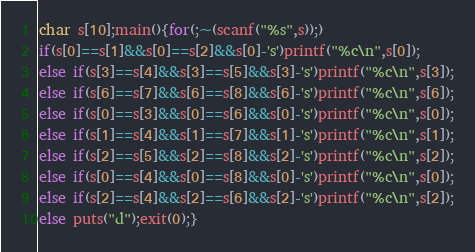Convert code to text. <code><loc_0><loc_0><loc_500><loc_500><_C_>char s[10];main(){for(;~(scanf("%s",s));)
if(s[0]==s[1]&&s[0]==s[2]&&s[0]-'s')printf("%c\n",s[0]);
else if(s[3]==s[4]&&s[3]==s[5]&&s[3]-'s')printf("%c\n",s[3]);
else if(s[6]==s[7]&&s[6]==s[8]&&s[6]-'s')printf("%c\n",s[6]);
else if(s[0]==s[3]&&s[0]==s[6]&&s[0]-'s')printf("%c\n",s[0]);
else if(s[1]==s[4]&&s[1]==s[7]&&s[1]-'s')printf("%c\n",s[1]);
else if(s[2]==s[5]&&s[2]==s[8]&&s[2]-'s')printf("%c\n",s[2]);
else if(s[0]==s[4]&&s[0]==s[8]&&s[0]-'s')printf("%c\n",s[0]);
else if(s[2]==s[4]&&s[2]==s[6]&&s[2]-'s')printf("%c\n",s[2]);
else puts("d");exit(0);}</code> 